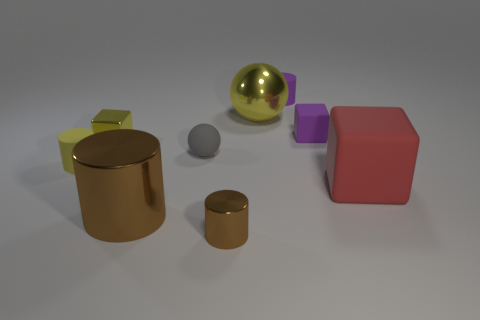Subtract all large brown cylinders. How many cylinders are left? 3 Subtract 1 cylinders. How many cylinders are left? 3 Subtract all yellow cylinders. How many cylinders are left? 3 Subtract 0 red cylinders. How many objects are left? 9 Subtract all cylinders. How many objects are left? 5 Subtract all brown cubes. Subtract all yellow cylinders. How many cubes are left? 3 Subtract all small metallic things. Subtract all big red cubes. How many objects are left? 6 Add 7 gray matte balls. How many gray matte balls are left? 8 Add 6 big matte objects. How many big matte objects exist? 7 